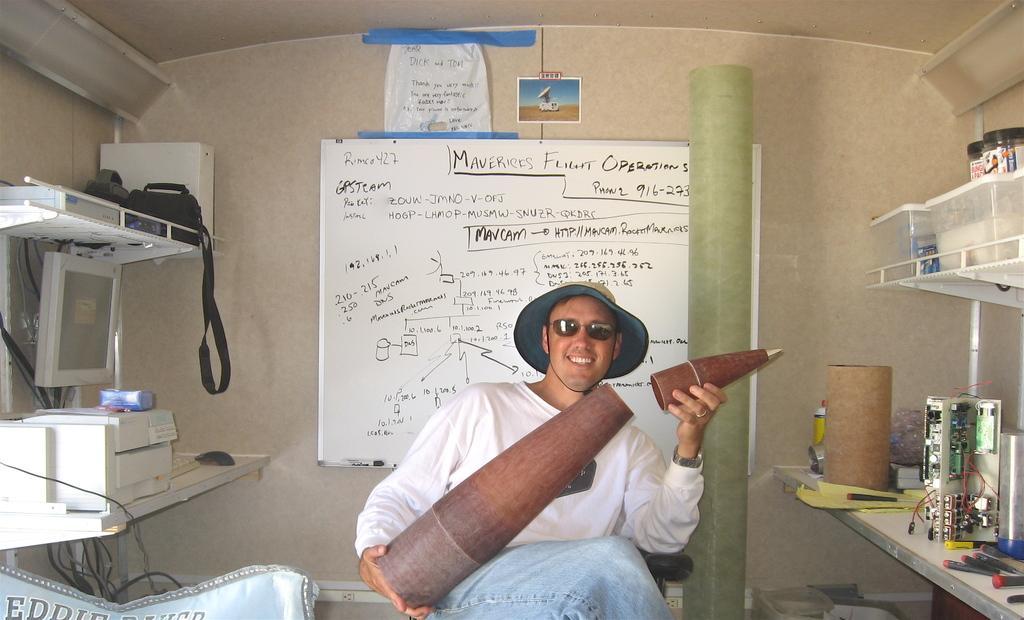Can you describe this image briefly? In the picture we can see a man sitting on the chair, wearing a white T-shirt and holding some wooden bottle with a cap and he is wearing a hat and black shades and smiling and behind him we can see a wall with white color board and something written on it and besides him we can see some racks with printing machines, monitor, and some black color bag, and on the other side we can see some cylindrical structures and some electronic devices. 